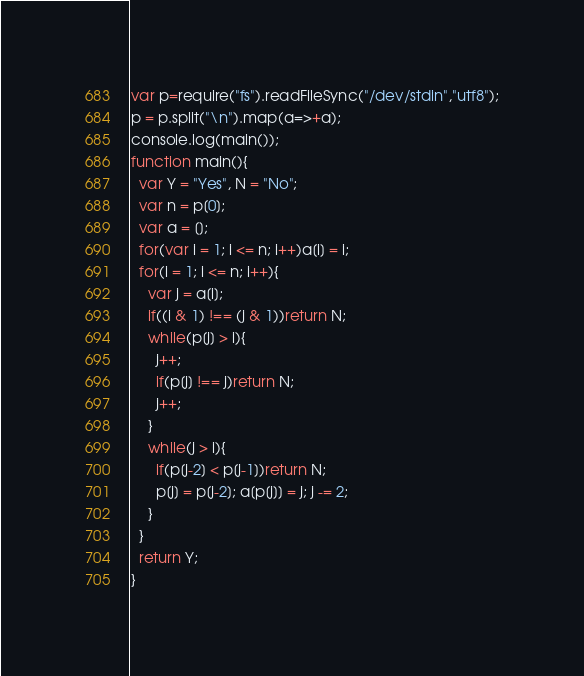Convert code to text. <code><loc_0><loc_0><loc_500><loc_500><_JavaScript_>var p=require("fs").readFileSync("/dev/stdin","utf8");
p = p.split("\n").map(a=>+a);
console.log(main());
function main(){
  var Y = "Yes", N = "No";
  var n = p[0];
  var a = [];
  for(var i = 1; i <= n; i++)a[i] = i;
  for(i = 1; i <= n; i++){
    var j = a[i];
    if((i & 1) !== (j & 1))return N;
    while(p[j] > i){
      j++;
      if(p[j] !== j)return N;
      j++;
    }
    while(j > i){
      if(p[j-2] < p[j-1])return N;
      p[j] = p[j-2]; a[p[j]] = j; j -= 2;
    }
  }
  return Y;
}</code> 